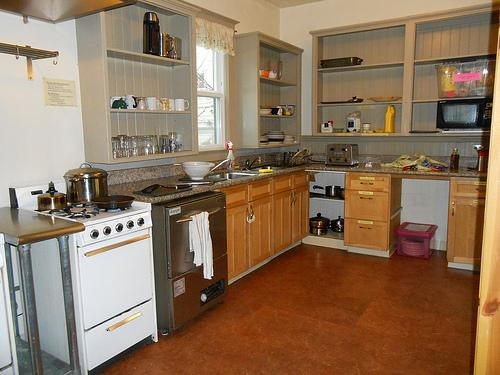Question: where was the pic taken?
Choices:
A. In the living room.
B. In the dining room.
C. In the kitchen.
D. In a bedroom.
Answer with the letter. Answer: C Question: who is in the kitchen?
Choices:
A. A woman.
B. A man.
C. A child.
D. No one.
Answer with the letter. Answer: D Question: when was the pic taken?
Choices:
A. During the morning.
B. During the afternoon.
C. During night.
D. During the day.
Answer with the letter. Answer: D 